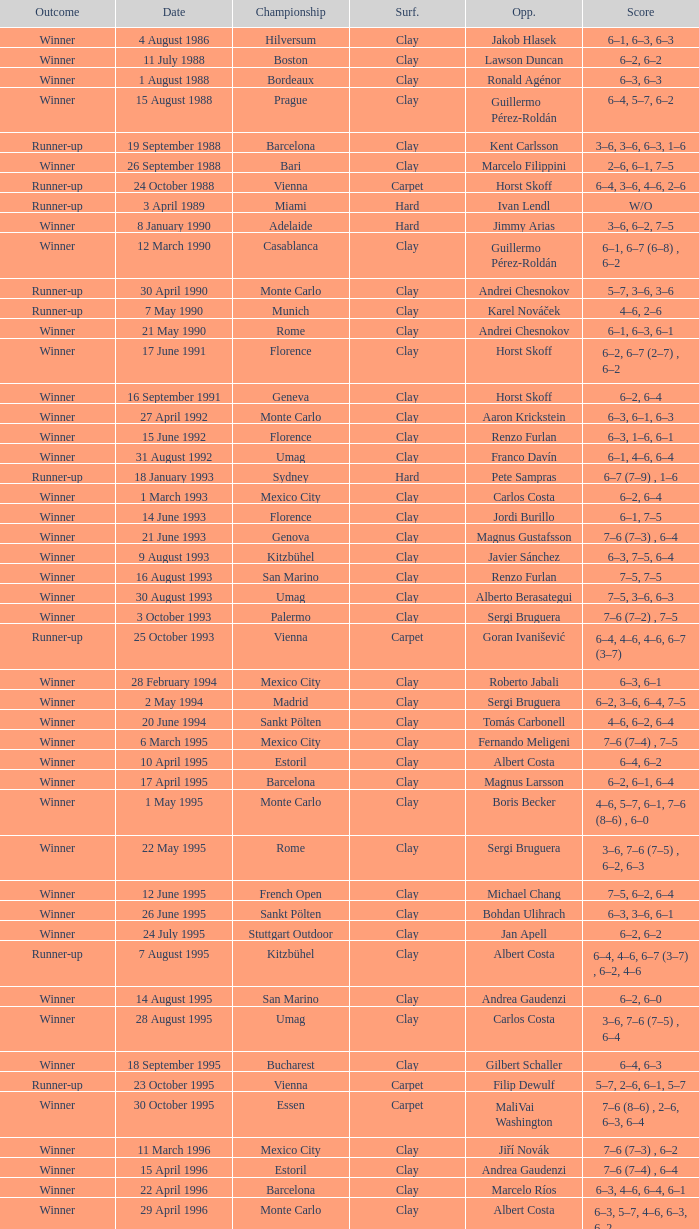What is the score when the championship is rome and the opponent is richard krajicek? 6–2, 6–4, 3–6, 6–3. 